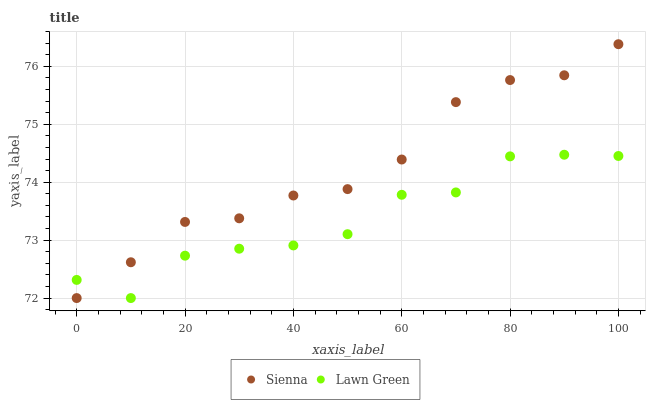Does Lawn Green have the minimum area under the curve?
Answer yes or no. Yes. Does Sienna have the maximum area under the curve?
Answer yes or no. Yes. Does Lawn Green have the maximum area under the curve?
Answer yes or no. No. Is Sienna the smoothest?
Answer yes or no. Yes. Is Lawn Green the roughest?
Answer yes or no. Yes. Is Lawn Green the smoothest?
Answer yes or no. No. Does Sienna have the lowest value?
Answer yes or no. Yes. Does Sienna have the highest value?
Answer yes or no. Yes. Does Lawn Green have the highest value?
Answer yes or no. No. Does Lawn Green intersect Sienna?
Answer yes or no. Yes. Is Lawn Green less than Sienna?
Answer yes or no. No. Is Lawn Green greater than Sienna?
Answer yes or no. No. 